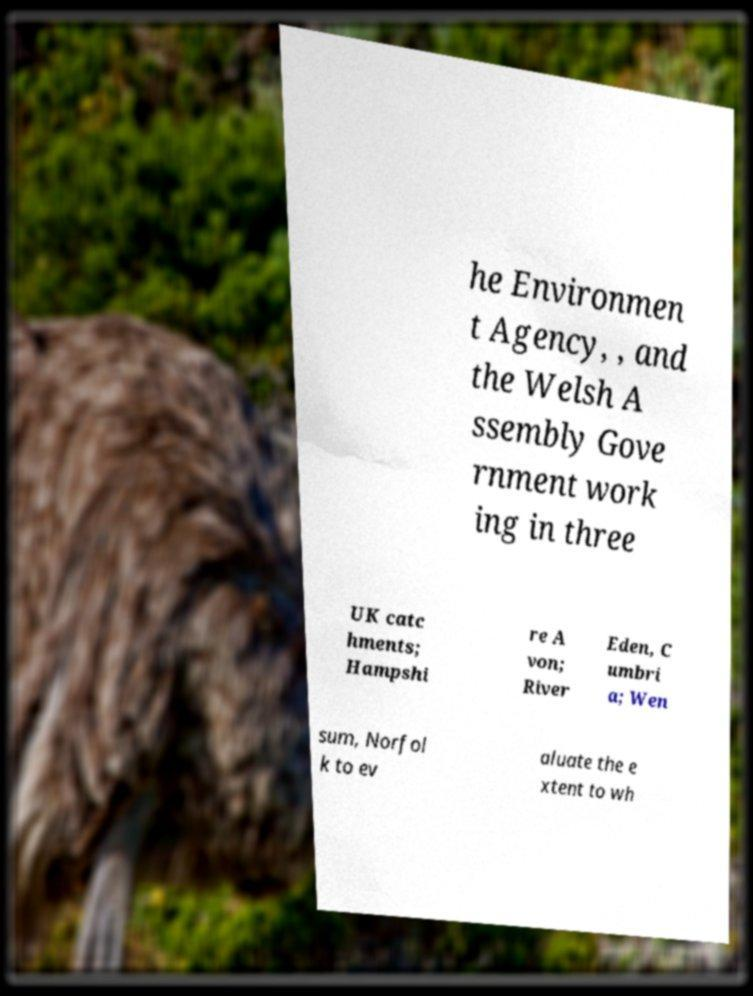For documentation purposes, I need the text within this image transcribed. Could you provide that? he Environmen t Agency, , and the Welsh A ssembly Gove rnment work ing in three UK catc hments; Hampshi re A von; River Eden, C umbri a; Wen sum, Norfol k to ev aluate the e xtent to wh 